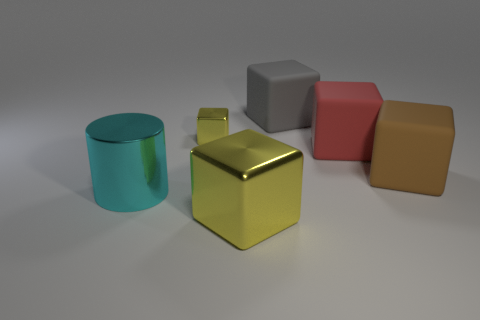Subtract 2 blocks. How many blocks are left? 3 Subtract all red blocks. How many blocks are left? 4 Subtract all gray cubes. How many cubes are left? 4 Add 1 large purple cylinders. How many objects exist? 7 Subtract all gray cubes. Subtract all cyan cylinders. How many cubes are left? 4 Subtract all cylinders. How many objects are left? 5 Add 5 gray rubber blocks. How many gray rubber blocks exist? 6 Subtract 0 purple blocks. How many objects are left? 6 Subtract all large yellow objects. Subtract all small objects. How many objects are left? 4 Add 6 big metallic objects. How many big metallic objects are left? 8 